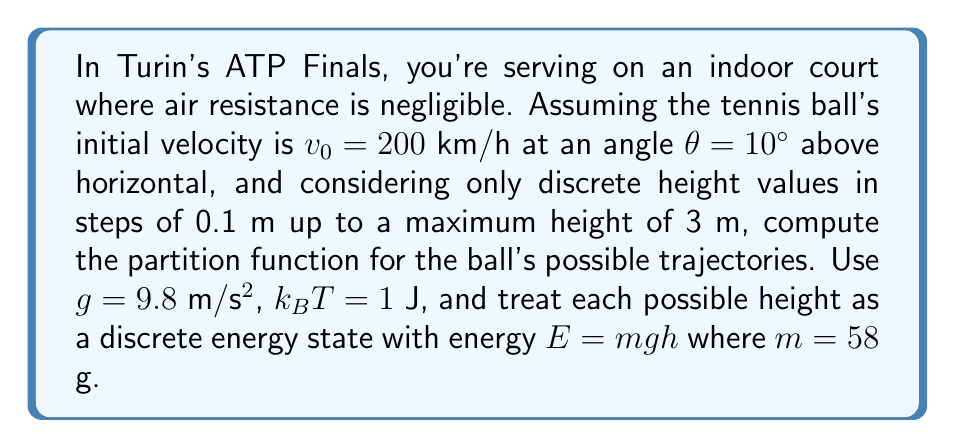Give your solution to this math problem. To solve this problem, we'll follow these steps:

1) First, we need to calculate the time the ball takes to reach its maximum height:
   $$v_y = v_0 \sin(\theta) - gt$$
   At max height, $v_y = 0$, so:
   $$0 = v_0 \sin(\theta) - gt_{max}$$
   $$t_{max} = \frac{v_0 \sin(\theta)}{g}$$

2) Convert initial velocity to m/s:
   $$v_0 = 200 \text{ km/h} = 55.56 \text{ m/s}$$

3) Calculate $t_{max}$:
   $$t_{max} = \frac{55.56 \sin(10°)}{9.8} = 0.98 \text{ s}$$

4) Calculate max height:
   $$h_{max} = v_0 t_{max} \sin(\theta) - \frac{1}{2}gt_{max}^2 = 2.67 \text{ m}$$

5) The partition function is given by:
   $$Z = \sum_{i} e^{-E_i/k_BT}$$
   where $E_i = mgh_i$

6) We have discrete heights from 0 to 3 m in steps of 0.1 m, so we sum over these:
   $$Z = \sum_{h=0}^{3} e^{-mgh/k_BT}$$
   where $h$ increases in steps of 0.1 m

7) Substituting the values:
   $$Z = \sum_{h=0}^{3} e^{-(0.058)(9.8)(h)/1} = \sum_{h=0}^{3} e^{-0.5684h}$$

8) Calculating this sum for h = 0, 0.1, 0.2, ..., 3.0:
   $$Z = 1 + 0.9448 + 0.8925 + ... + 0.1817 = 11.7647$$
Answer: $Z \approx 11.7647$ 